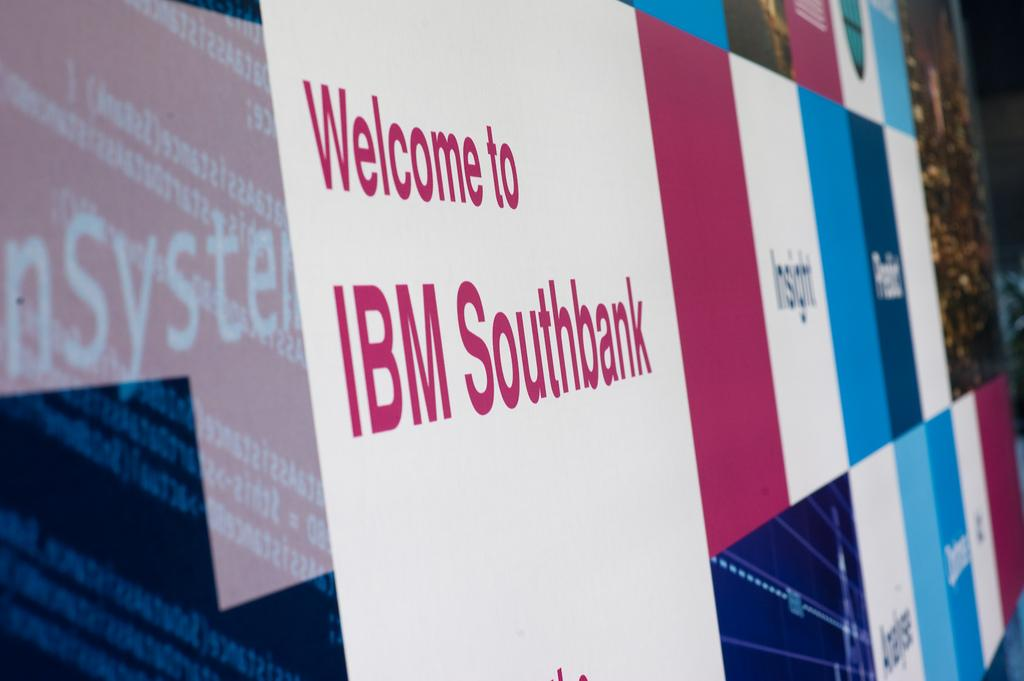<image>
Provide a brief description of the given image. A purple and blue sign welcomes people to IBM Southbank. 